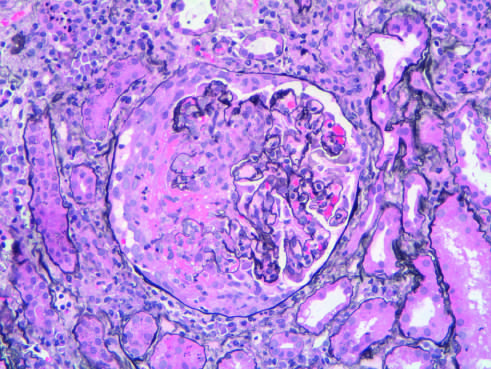what is the segmental distribution in this case?
Answer the question using a single word or phrase. Typical of anca (anti-neutrophil cytoplasmic antibody)- associated crescentic glomerulonephritis 